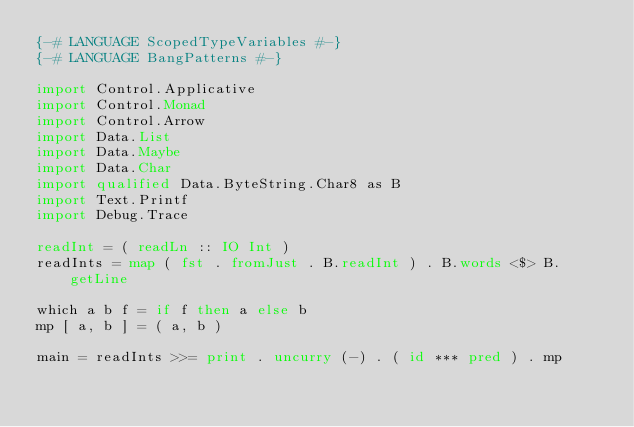<code> <loc_0><loc_0><loc_500><loc_500><_Haskell_>{-# LANGUAGE ScopedTypeVariables #-}
{-# LANGUAGE BangPatterns #-}

import Control.Applicative
import Control.Monad
import Control.Arrow
import Data.List
import Data.Maybe
import Data.Char
import qualified Data.ByteString.Char8 as B
import Text.Printf
import Debug.Trace

readInt = ( readLn :: IO Int )
readInts = map ( fst . fromJust . B.readInt ) . B.words <$> B.getLine

which a b f = if f then a else b
mp [ a, b ] = ( a, b )

main = readInts >>= print . uncurry (-) . ( id *** pred ) . mp</code> 